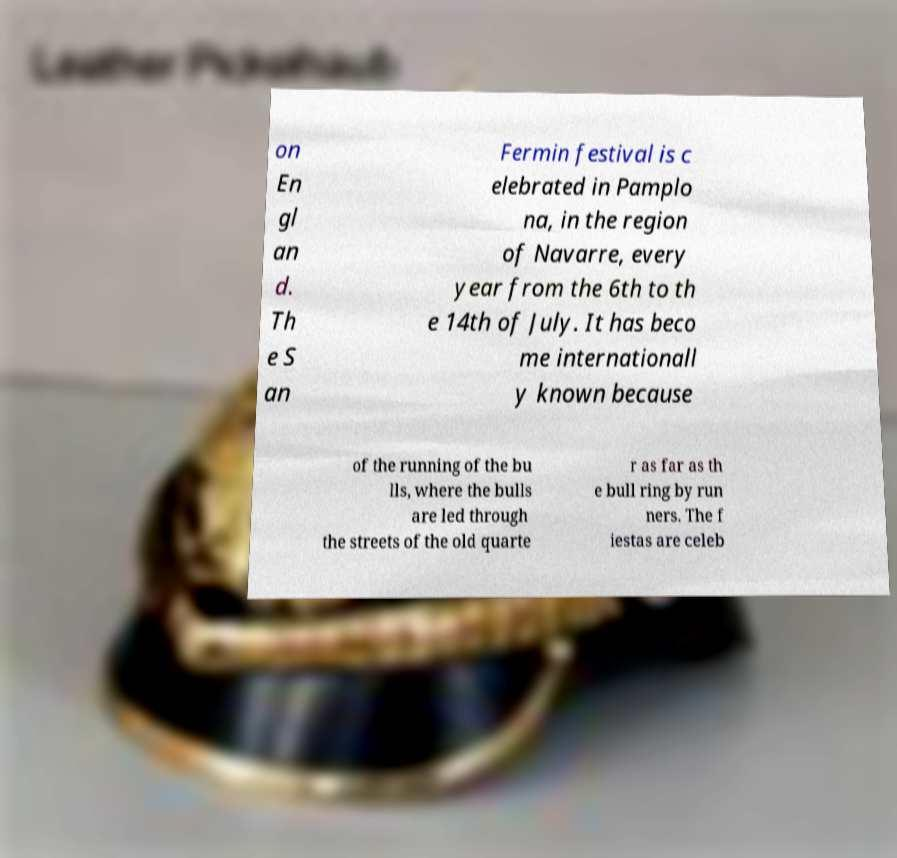I need the written content from this picture converted into text. Can you do that? on En gl an d. Th e S an Fermin festival is c elebrated in Pamplo na, in the region of Navarre, every year from the 6th to th e 14th of July. It has beco me internationall y known because of the running of the bu lls, where the bulls are led through the streets of the old quarte r as far as th e bull ring by run ners. The f iestas are celeb 